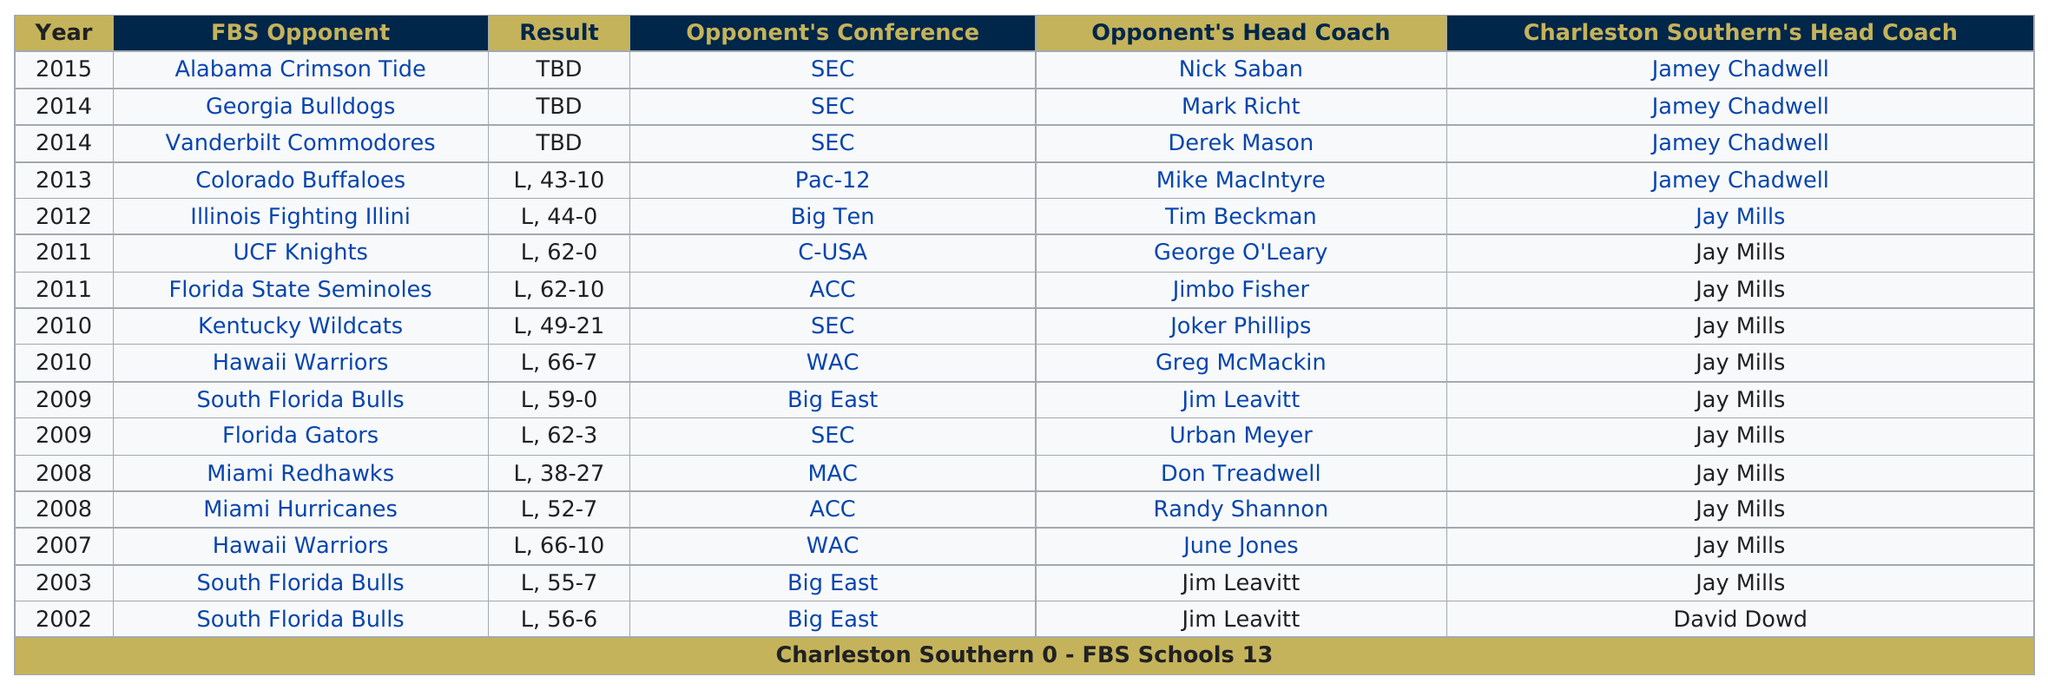List a handful of essential elements in this visual. Prior to facing the Georgia Bulldogs, the opponent was the Vanderbilt Commodores. In the year 2003, Jay Mills began his first year. After defeating the Florida State Seminoles, the UCF Knights played against Charleston played three games against Big East teams. The South Florida Bulls faced the opponent that followed the Florida Gators after their game. 